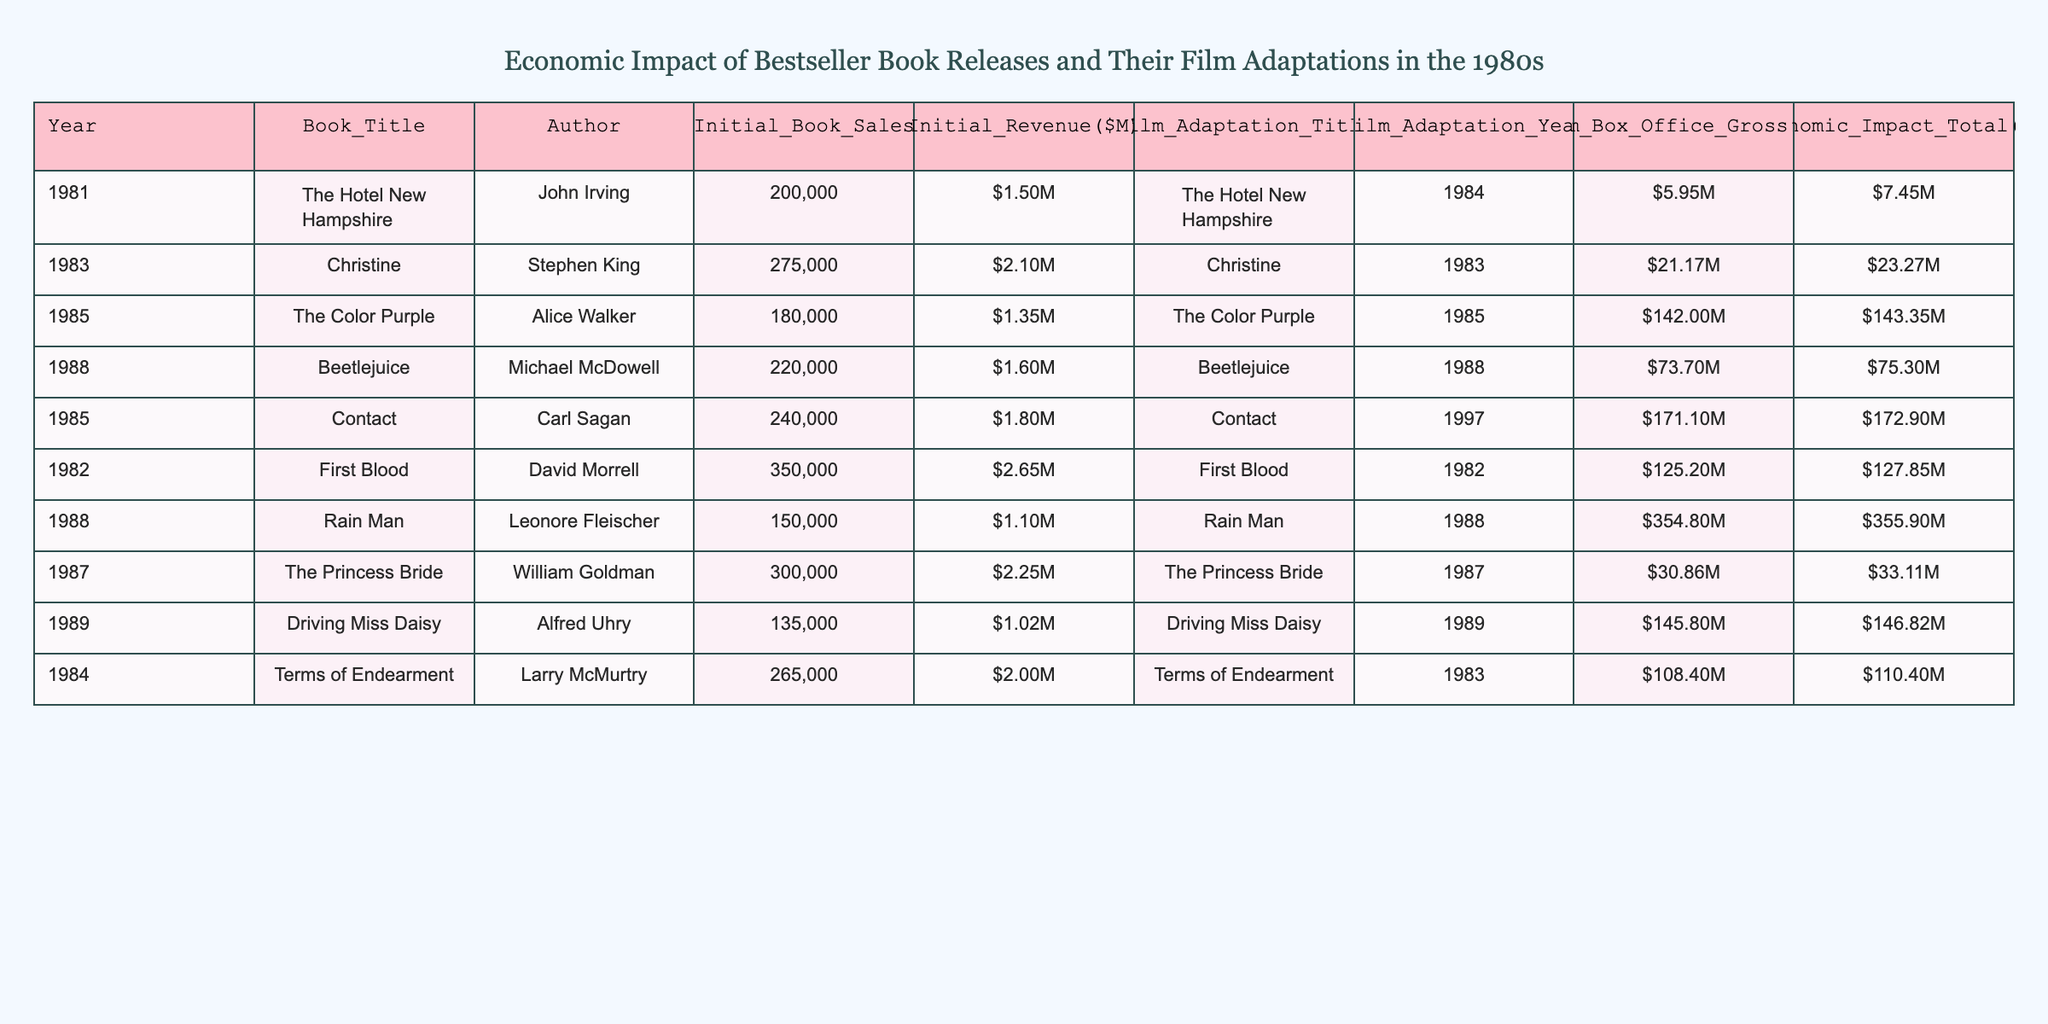What was the initial revenue of "Rain Man"? The initial revenue for "Rain Man" is listed in the table under the column for Initial Revenue, which shows as $1.1M.
Answer: $1.1M Which book adaptation grossed the highest at the box office? The table shows that "Rain Man," with a box office gross of $354.8M, has the highest gross compared to other adaptations listed.
Answer: $354.8M What was the total economic impact of "The Color Purple"? The economic impact total for "The Color Purple" is indicated in the last column of the table, which sums to $143.35M.
Answer: $143.35M How much more did "Contact" earn at the box office compared to "The Princess Bride"? The box office gross for "Contact" is $171.1M and for "The Princess Bride" it is $30.86M. The difference is calculated as $171.1M - $30.86M = $140.24M.
Answer: $140.24M Did "Terms of Endearment" earn more at the box office compared to "Christine"? "Terms of Endearment" had a box office gross of $108.4M, while "Christine" grossed $21.17M. Since $108.4M is greater than $21.17M, the answer is yes.
Answer: Yes Which author had the highest average economic impact across their adaptations listed in the table? To find the author with the highest average economic impact, we sum the economic impacts for each author: John Irving has $7.45M, Stephen King has $23.27M, Alice Walker has $143.35M, Michael McDowell has $75.3M, Carl Sagan has $172.9M, David Morrell has $127.85M, Leonore Fleischer has $355.9M, William Goldman has $33.11M, and Alfred Uhry has $146.82M. The total for each author is calculated and averaged over the number of adaptations. Leonore Fleischer has the largest impact: $355.9M/1 = $355.9M (only one adaptation).
Answer: $355.9M What was the combined initial revenue of all the books released in 1985? In 1985, the initial revenues were for "The Color Purple" ($1.35M) and "Contact" ($1.8M). The combined revenue is calculated by summing these amounts: $1.35M + $1.8M = $3.15M.
Answer: $3.15M Was "Driving Miss Daisy" adapted from a novel that had higher initial sales than "Beetlejuice"? "Driving Miss Daisy" had initial sales of 135,000, while "Beetlejuice" had sales of 220,000. Since 135,000 is less than 220,000, the answer is no.
Answer: No Which film adaptation had the smallest total economic impact? Looking at the total economic impact column, "The Hotel New Hampshire" shows the smallest total impact of $7.45M compared to other adaptations.
Answer: $7.45M 